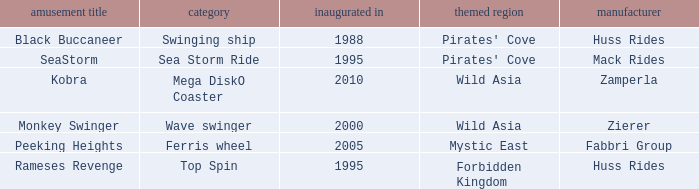Which ride opened after the 2000 Peeking Heights? Ferris wheel. 